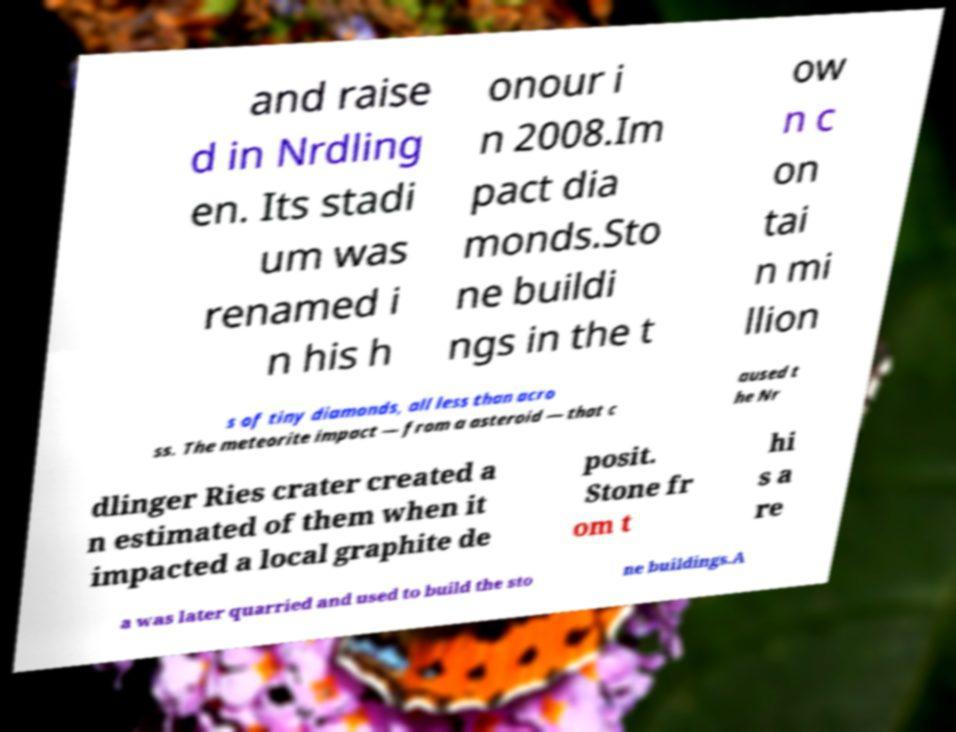Could you assist in decoding the text presented in this image and type it out clearly? and raise d in Nrdling en. Its stadi um was renamed i n his h onour i n 2008.Im pact dia monds.Sto ne buildi ngs in the t ow n c on tai n mi llion s of tiny diamonds, all less than acro ss. The meteorite impact — from a asteroid — that c aused t he Nr dlinger Ries crater created a n estimated of them when it impacted a local graphite de posit. Stone fr om t hi s a re a was later quarried and used to build the sto ne buildings.A 